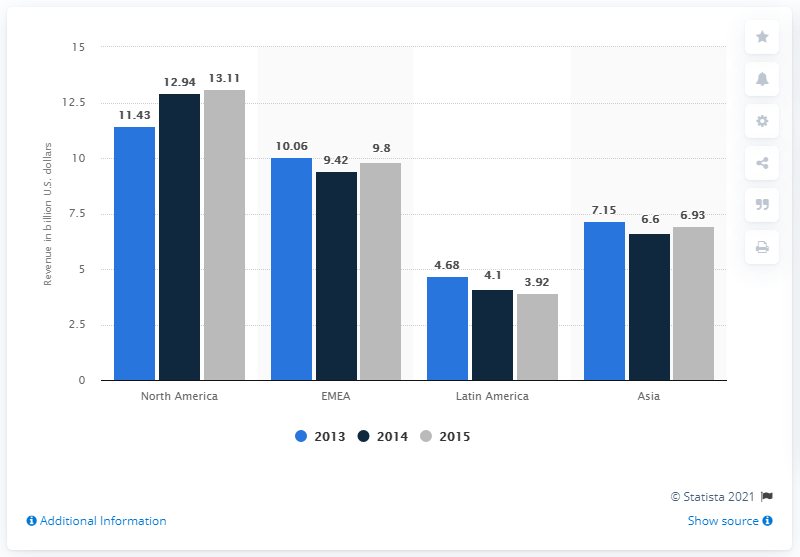Point out several critical features in this image. The blue bar chart displays a value of 4.68 for the category of Latin America. In 2015, Citigroup's revenue from Latin America was 3.92 billion dollars. The average value of all bars in the Asia category is 6.89. 